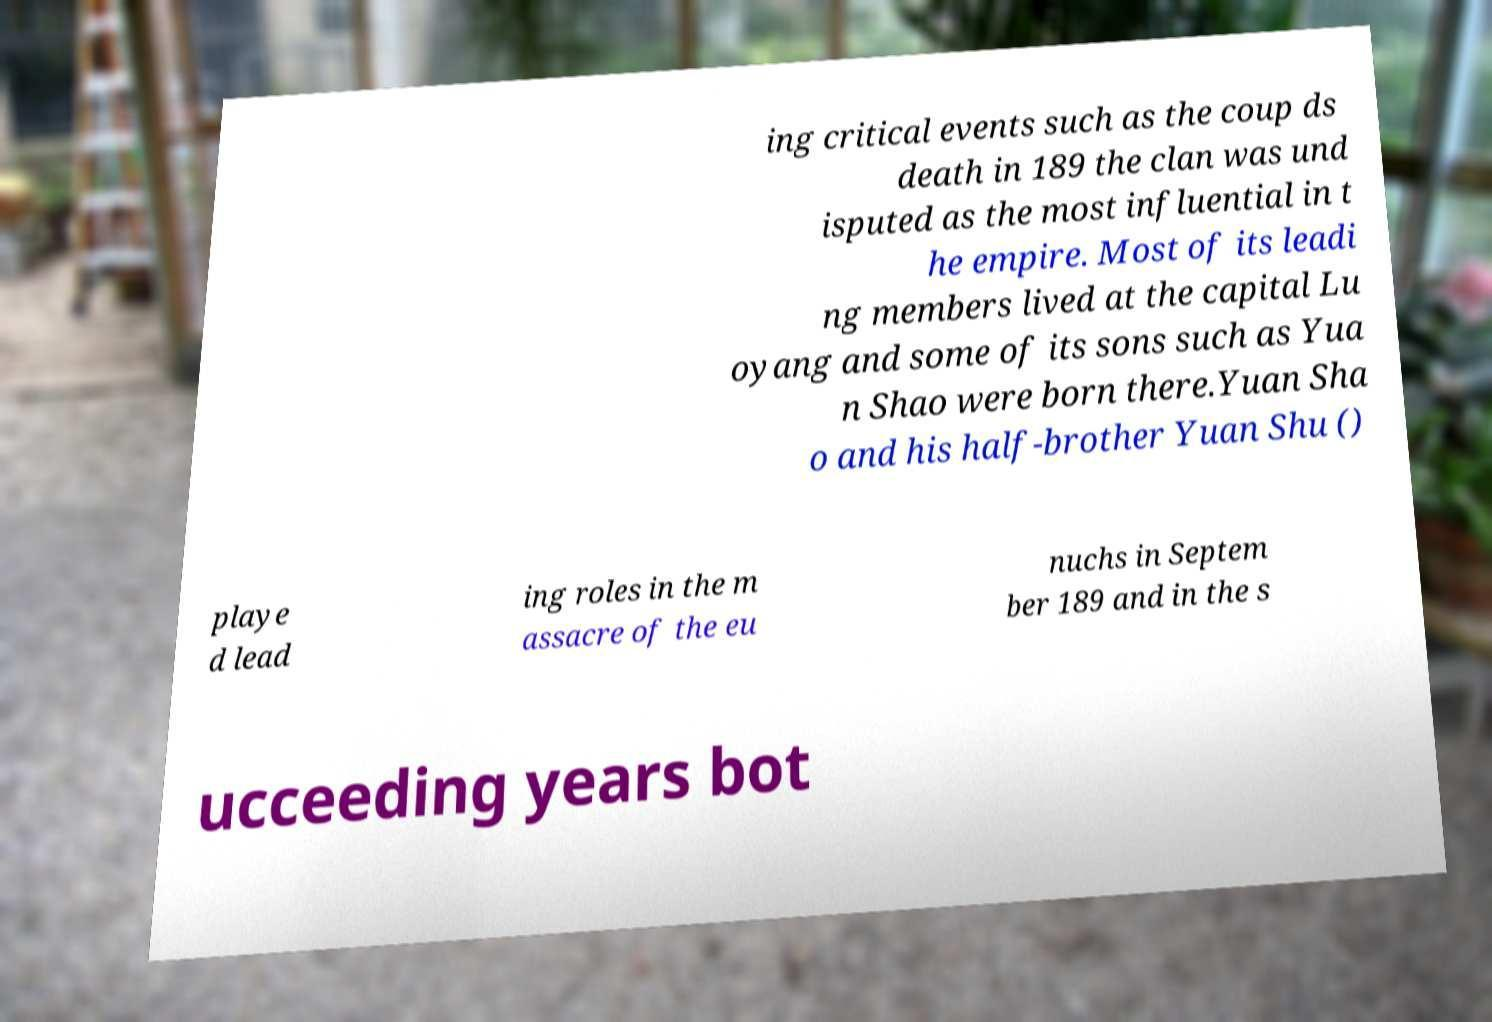Could you assist in decoding the text presented in this image and type it out clearly? ing critical events such as the coup ds death in 189 the clan was und isputed as the most influential in t he empire. Most of its leadi ng members lived at the capital Lu oyang and some of its sons such as Yua n Shao were born there.Yuan Sha o and his half-brother Yuan Shu () playe d lead ing roles in the m assacre of the eu nuchs in Septem ber 189 and in the s ucceeding years bot 